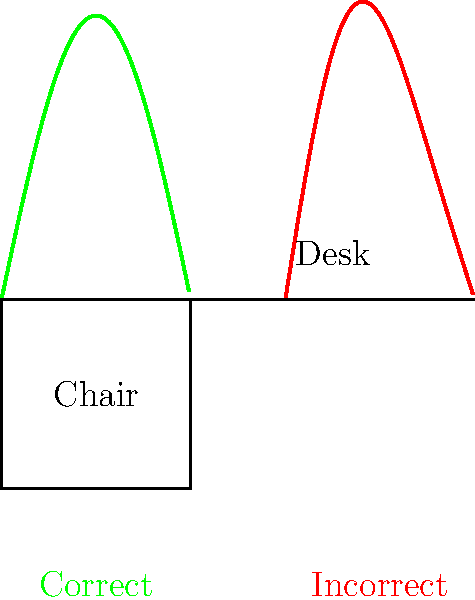As an educator and college president, you're concerned about the ergonomics of students' study environments. Based on the biomechanical principles illustrated in the diagram, what is the primary difference between the correct and incorrect spine alignments when sitting at a desk, and how might this impact a student's ability to focus during long study sessions? To answer this question, let's analyze the biomechanics of proper posture while sitting at a desk:

1. Correct posture (green line):
   - The spine maintains its natural S-curve
   - The lower back (lumbar region) has a slight inward curve
   - The upper back and neck are relatively straight

2. Incorrect posture (red line):
   - The spine has an exaggerated C-curve
   - The lower back is rounded outward (increased kyphosis)
   - The upper back and neck are hunched forward

3. Biomechanical implications:
   - Correct posture distributes body weight evenly across the spine
   - Incorrect posture increases stress on certain vertebrae and muscles

4. Impact on focus and study:
   - Correct posture reduces muscle strain and fatigue
   - Incorrect posture can lead to discomfort, pain, and decreased blood flow

5. Long-term effects:
   - Maintaining correct posture can prevent chronic back pain and related issues
   - Prolonged incorrect posture may lead to musculoskeletal disorders

The primary difference is the maintenance of the spine's natural curves in the correct posture, which minimizes stress on the musculoskeletal system. This can significantly impact a student's ability to focus during long study sessions by reducing discomfort and fatigue, potentially leading to improved concentration and learning outcomes.
Answer: Maintenance of natural spinal curves, reducing musculoskeletal stress and improving focus 